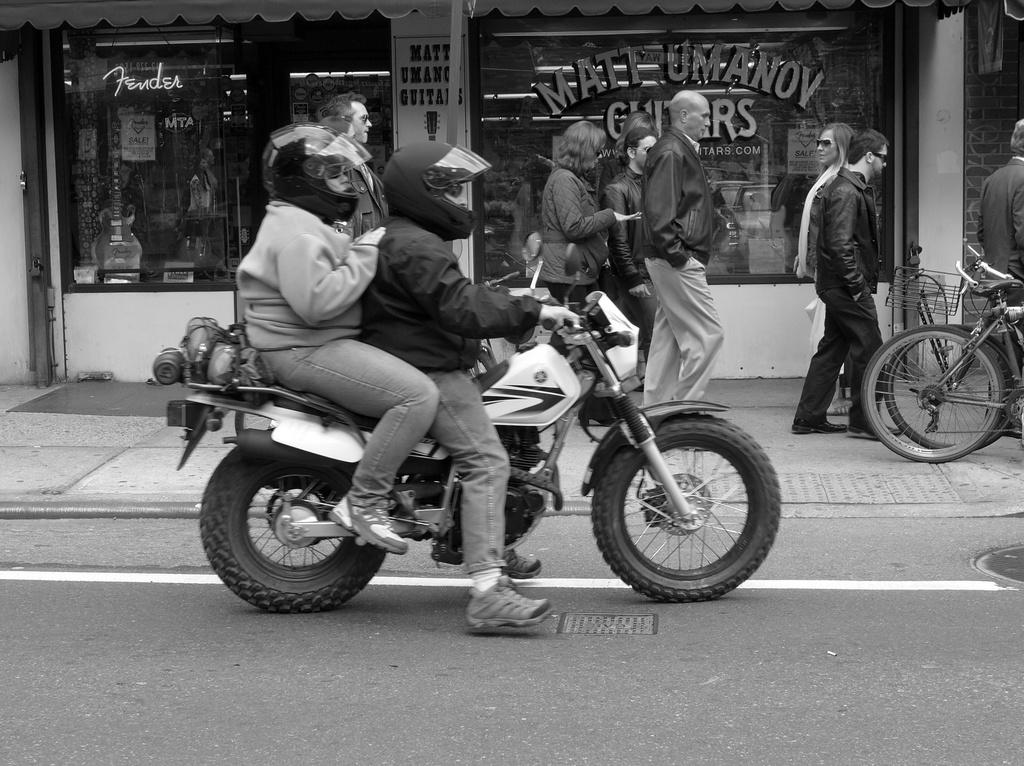What are the couple members doing in the image? The couple is riding a motorcycle in the image. What safety precautions are they taking? Both the couple members are wearing helmets. What can be seen in the background of the image? There is a store in the background. What is happening on the footpath in the image? There are people walking on the footpath. What type of bushes can be seen growing in the tub in the image? There is no tub or bushes present in the image; it features a couple on a motorcycle with people walking on the footpath and a store in the background. 